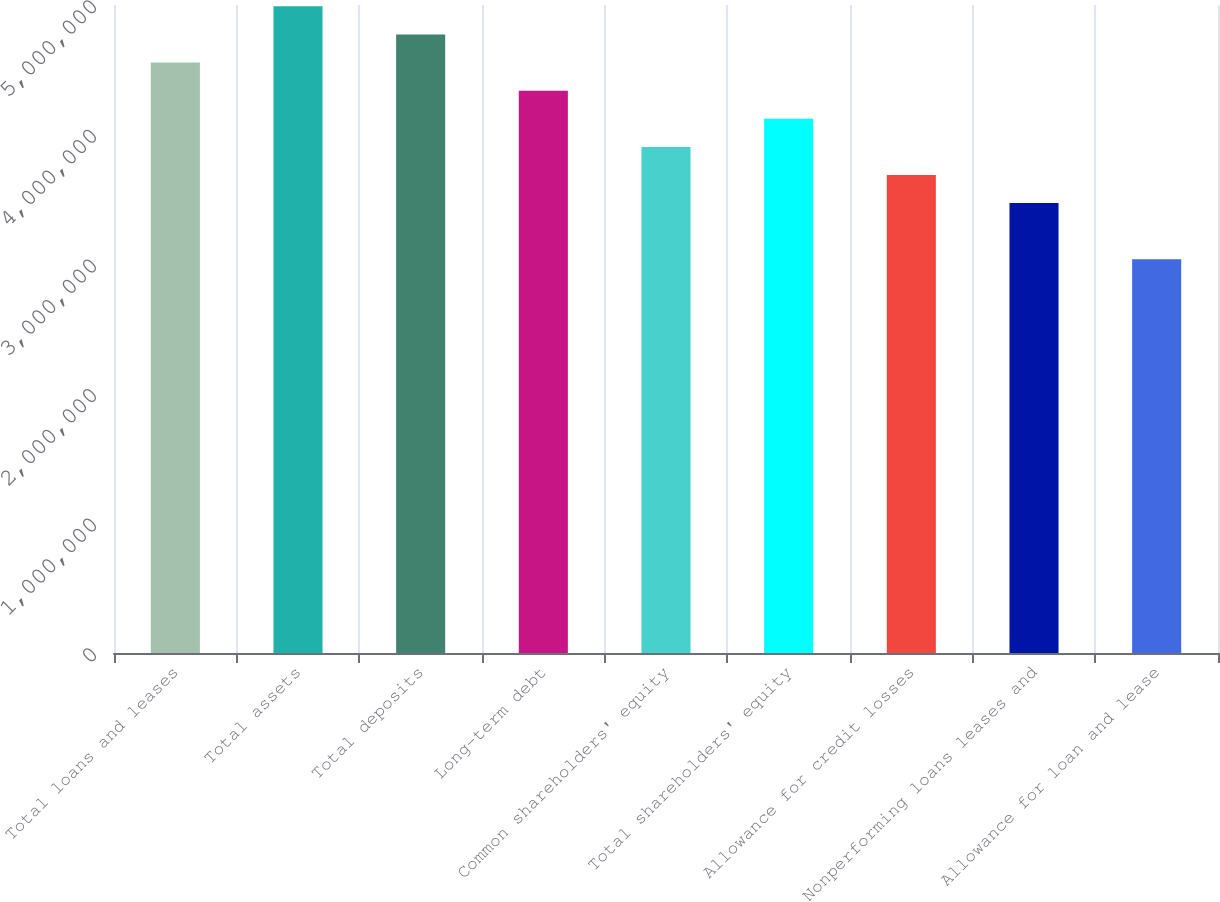<chart> <loc_0><loc_0><loc_500><loc_500><bar_chart><fcel>Total loans and leases<fcel>Total assets<fcel>Total deposits<fcel>Long-term debt<fcel>Common shareholders' equity<fcel>Total shareholders' equity<fcel>Allowance for credit losses<fcel>Nonperforming loans leases and<fcel>Allowance for loan and lease<nl><fcel>4.55606e+06<fcel>4.98998e+06<fcel>4.77302e+06<fcel>4.33911e+06<fcel>3.9052e+06<fcel>4.12215e+06<fcel>3.68824e+06<fcel>3.47129e+06<fcel>3.03738e+06<nl></chart> 